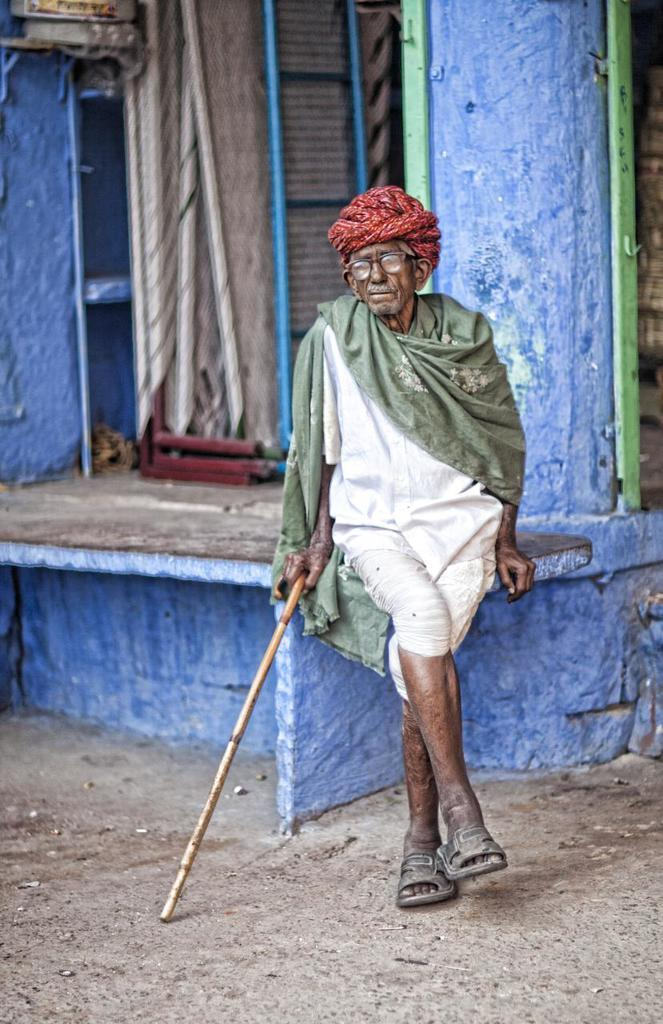What is the main subject in the foreground of the image? There is an old man in the foreground of the image. What is the old man holding in the image? The old man is holding a stick. What is the old man sitting on in the image? The old man is sitting on a stone surface. What structures can be seen in the background of the image? There is a pillar, a ladder, and a wall in the background of the image. What other objects are present in the background of the image? There are other objects in the background of the image. What type of riddle is the old man trying to solve in the image? There is no riddle present in the image; the old man is simply holding a stick and sitting on a stone surface. Can you tell me where the key is hidden in the image? There is no key present in the image, so its location cannot be determined. 